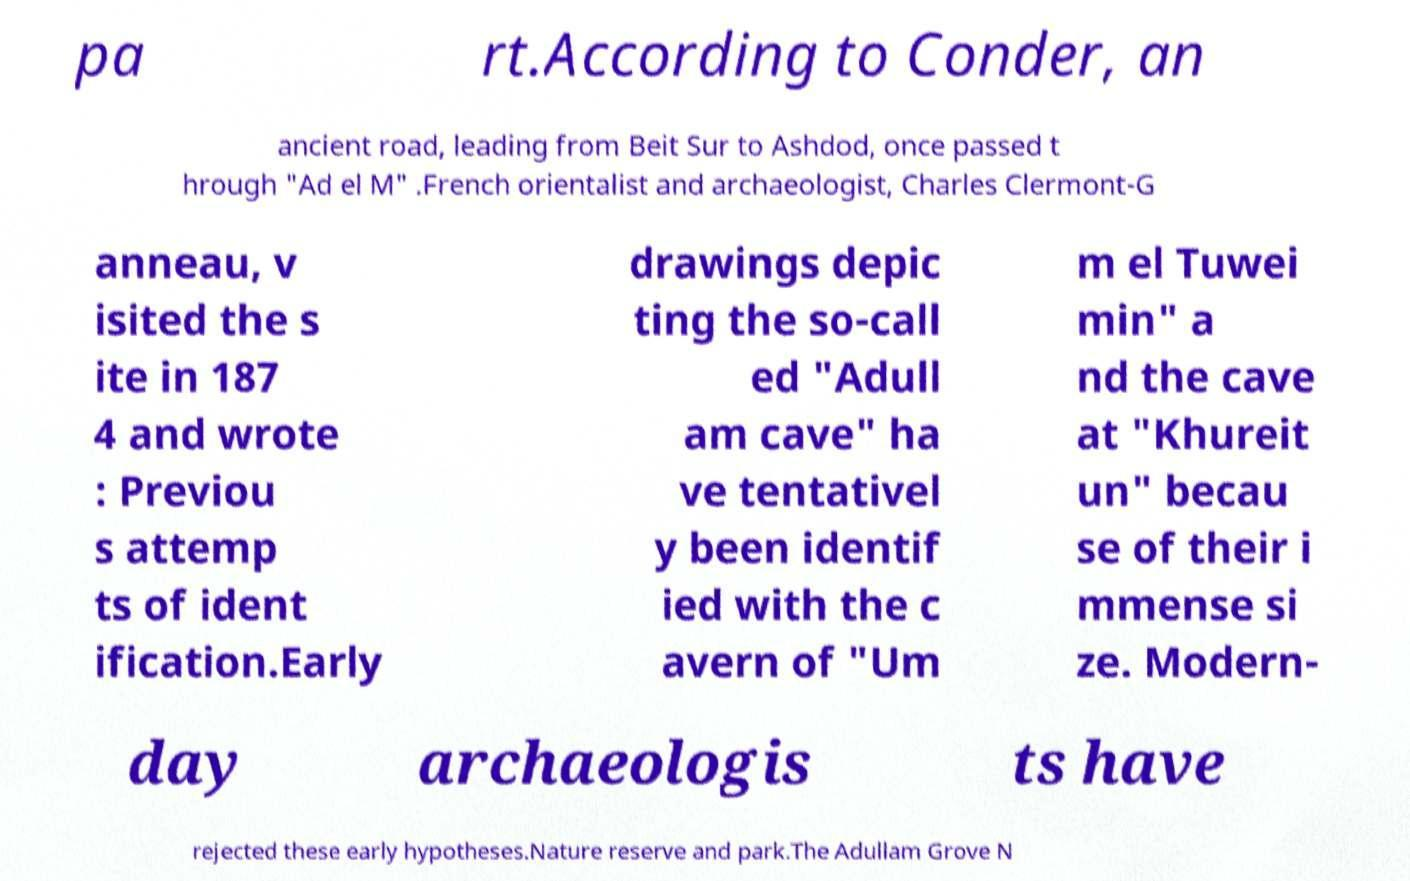Can you read and provide the text displayed in the image?This photo seems to have some interesting text. Can you extract and type it out for me? pa rt.According to Conder, an ancient road, leading from Beit Sur to Ashdod, once passed t hrough "Ad el M" .French orientalist and archaeologist, Charles Clermont-G anneau, v isited the s ite in 187 4 and wrote : Previou s attemp ts of ident ification.Early drawings depic ting the so-call ed "Adull am cave" ha ve tentativel y been identif ied with the c avern of "Um m el Tuwei min" a nd the cave at "Khureit un" becau se of their i mmense si ze. Modern- day archaeologis ts have rejected these early hypotheses.Nature reserve and park.The Adullam Grove N 